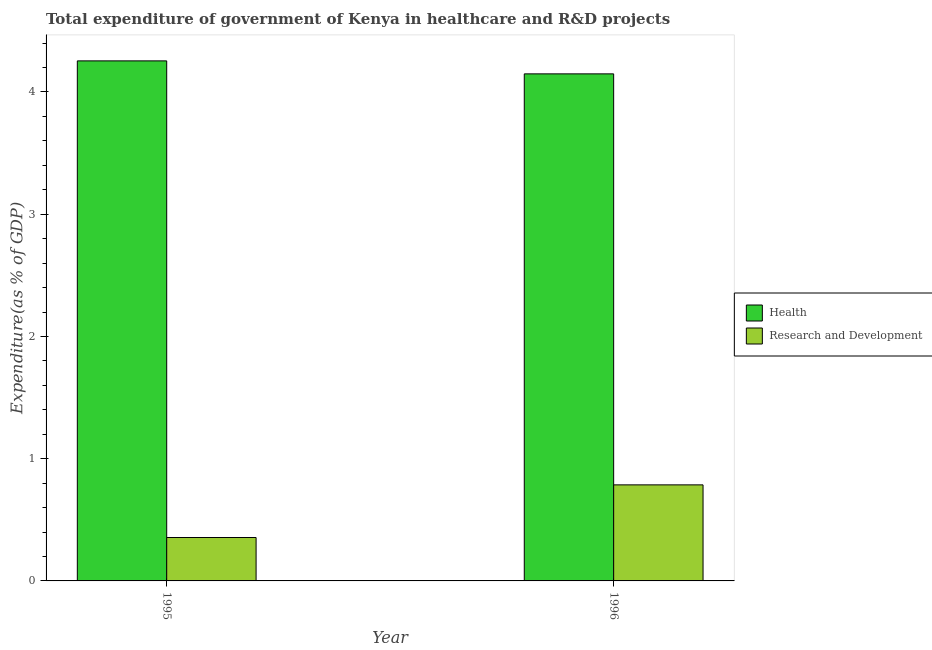How many different coloured bars are there?
Your answer should be very brief. 2. How many groups of bars are there?
Your answer should be compact. 2. Are the number of bars per tick equal to the number of legend labels?
Ensure brevity in your answer.  Yes. How many bars are there on the 2nd tick from the left?
Offer a terse response. 2. How many bars are there on the 2nd tick from the right?
Give a very brief answer. 2. What is the expenditure in healthcare in 1996?
Provide a succinct answer. 4.15. Across all years, what is the maximum expenditure in healthcare?
Keep it short and to the point. 4.25. Across all years, what is the minimum expenditure in r&d?
Provide a short and direct response. 0.36. In which year was the expenditure in healthcare maximum?
Offer a terse response. 1995. In which year was the expenditure in r&d minimum?
Provide a succinct answer. 1995. What is the total expenditure in r&d in the graph?
Your response must be concise. 1.14. What is the difference between the expenditure in r&d in 1995 and that in 1996?
Make the answer very short. -0.43. What is the difference between the expenditure in r&d in 1995 and the expenditure in healthcare in 1996?
Provide a succinct answer. -0.43. What is the average expenditure in r&d per year?
Make the answer very short. 0.57. In how many years, is the expenditure in r&d greater than 1.8 %?
Your answer should be compact. 0. What is the ratio of the expenditure in r&d in 1995 to that in 1996?
Keep it short and to the point. 0.45. In how many years, is the expenditure in healthcare greater than the average expenditure in healthcare taken over all years?
Make the answer very short. 1. What does the 1st bar from the left in 1996 represents?
Give a very brief answer. Health. What does the 1st bar from the right in 1996 represents?
Provide a short and direct response. Research and Development. How many bars are there?
Make the answer very short. 4. Are all the bars in the graph horizontal?
Your response must be concise. No. Where does the legend appear in the graph?
Give a very brief answer. Center right. How many legend labels are there?
Ensure brevity in your answer.  2. How are the legend labels stacked?
Ensure brevity in your answer.  Vertical. What is the title of the graph?
Provide a short and direct response. Total expenditure of government of Kenya in healthcare and R&D projects. Does "Services" appear as one of the legend labels in the graph?
Keep it short and to the point. No. What is the label or title of the Y-axis?
Provide a succinct answer. Expenditure(as % of GDP). What is the Expenditure(as % of GDP) in Health in 1995?
Provide a succinct answer. 4.25. What is the Expenditure(as % of GDP) in Research and Development in 1995?
Give a very brief answer. 0.36. What is the Expenditure(as % of GDP) of Health in 1996?
Your response must be concise. 4.15. What is the Expenditure(as % of GDP) in Research and Development in 1996?
Your answer should be compact. 0.79. Across all years, what is the maximum Expenditure(as % of GDP) in Health?
Your response must be concise. 4.25. Across all years, what is the maximum Expenditure(as % of GDP) of Research and Development?
Offer a terse response. 0.79. Across all years, what is the minimum Expenditure(as % of GDP) of Health?
Your answer should be very brief. 4.15. Across all years, what is the minimum Expenditure(as % of GDP) of Research and Development?
Keep it short and to the point. 0.36. What is the total Expenditure(as % of GDP) of Health in the graph?
Offer a terse response. 8.4. What is the total Expenditure(as % of GDP) in Research and Development in the graph?
Provide a short and direct response. 1.14. What is the difference between the Expenditure(as % of GDP) in Health in 1995 and that in 1996?
Your answer should be compact. 0.11. What is the difference between the Expenditure(as % of GDP) in Research and Development in 1995 and that in 1996?
Make the answer very short. -0.43. What is the difference between the Expenditure(as % of GDP) in Health in 1995 and the Expenditure(as % of GDP) in Research and Development in 1996?
Provide a short and direct response. 3.47. What is the average Expenditure(as % of GDP) of Health per year?
Provide a short and direct response. 4.2. What is the average Expenditure(as % of GDP) of Research and Development per year?
Your answer should be very brief. 0.57. In the year 1995, what is the difference between the Expenditure(as % of GDP) in Health and Expenditure(as % of GDP) in Research and Development?
Your answer should be compact. 3.9. In the year 1996, what is the difference between the Expenditure(as % of GDP) of Health and Expenditure(as % of GDP) of Research and Development?
Provide a succinct answer. 3.36. What is the ratio of the Expenditure(as % of GDP) of Health in 1995 to that in 1996?
Make the answer very short. 1.03. What is the ratio of the Expenditure(as % of GDP) in Research and Development in 1995 to that in 1996?
Offer a very short reply. 0.45. What is the difference between the highest and the second highest Expenditure(as % of GDP) of Health?
Your response must be concise. 0.11. What is the difference between the highest and the second highest Expenditure(as % of GDP) of Research and Development?
Your answer should be very brief. 0.43. What is the difference between the highest and the lowest Expenditure(as % of GDP) of Health?
Make the answer very short. 0.11. What is the difference between the highest and the lowest Expenditure(as % of GDP) in Research and Development?
Your answer should be compact. 0.43. 